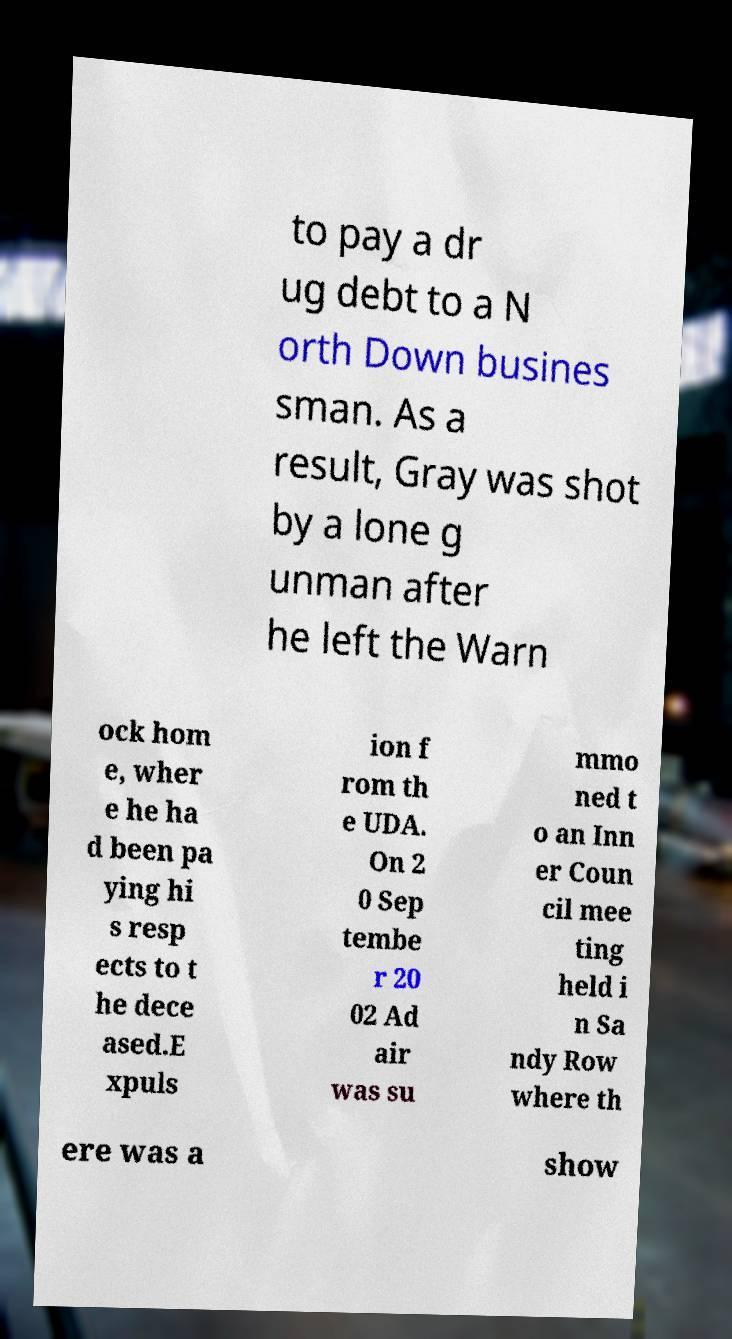I need the written content from this picture converted into text. Can you do that? to pay a dr ug debt to a N orth Down busines sman. As a result, Gray was shot by a lone g unman after he left the Warn ock hom e, wher e he ha d been pa ying hi s resp ects to t he dece ased.E xpuls ion f rom th e UDA. On 2 0 Sep tembe r 20 02 Ad air was su mmo ned t o an Inn er Coun cil mee ting held i n Sa ndy Row where th ere was a show 